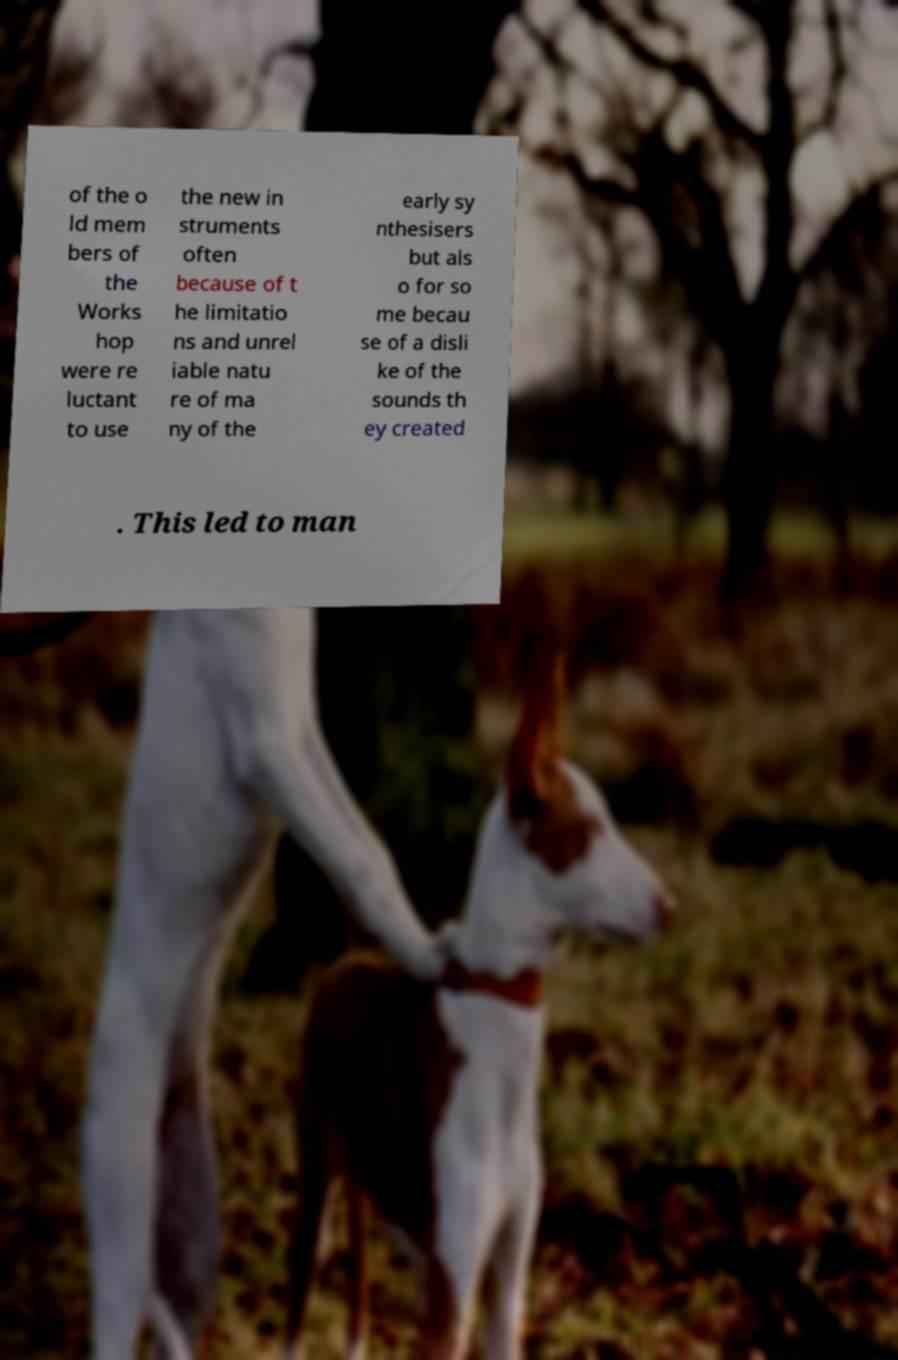I need the written content from this picture converted into text. Can you do that? of the o ld mem bers of the Works hop were re luctant to use the new in struments often because of t he limitatio ns and unrel iable natu re of ma ny of the early sy nthesisers but als o for so me becau se of a disli ke of the sounds th ey created . This led to man 